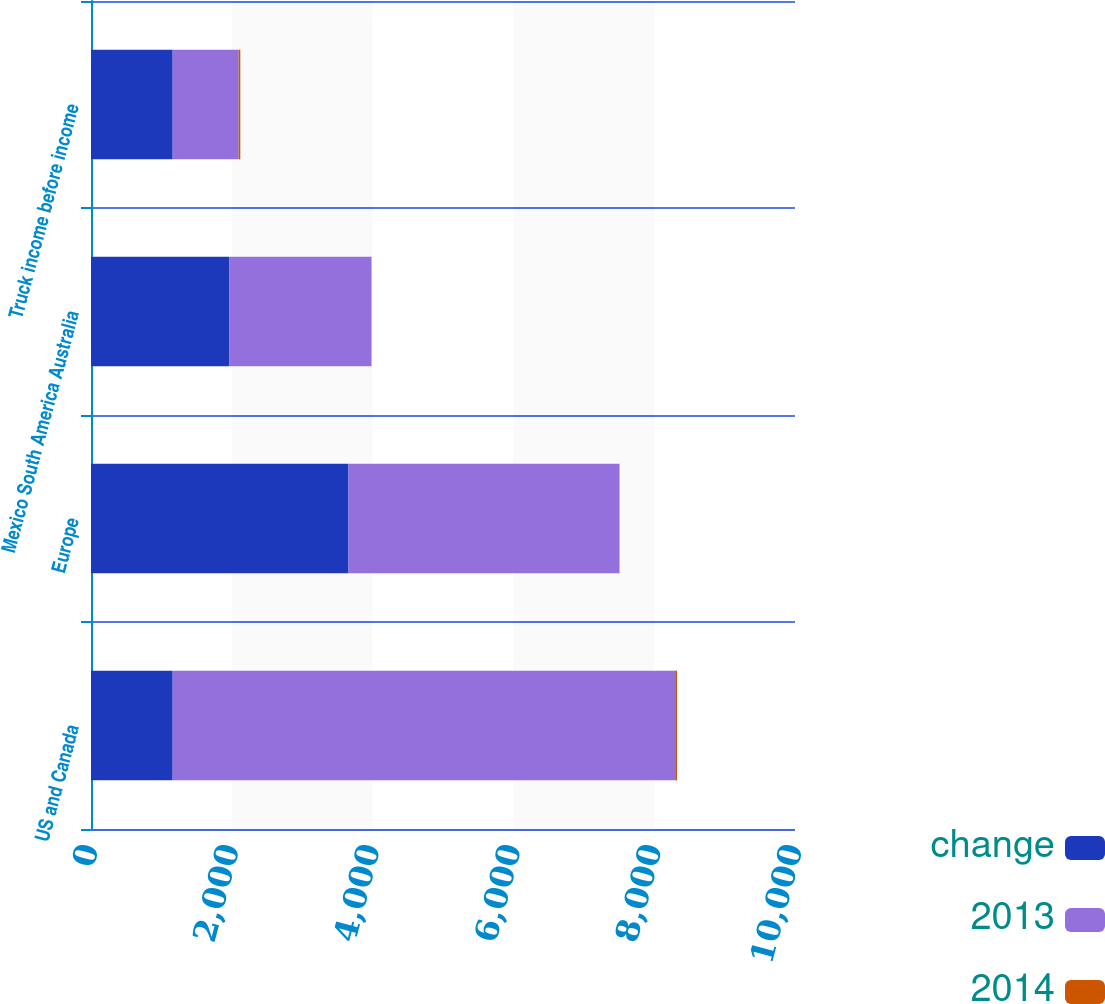<chart> <loc_0><loc_0><loc_500><loc_500><stacked_bar_chart><ecel><fcel>US and Canada<fcel>Europe<fcel>Mexico South America Australia<fcel>Truck income before income<nl><fcel>change<fcel>1160.1<fcel>3657.6<fcel>1961.9<fcel>1160.1<nl><fcel>2013<fcel>7138.1<fcel>3844.4<fcel>2020.4<fcel>936.7<nl><fcel>2014<fcel>26<fcel>5<fcel>3<fcel>24<nl></chart> 